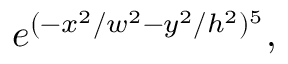Convert formula to latex. <formula><loc_0><loc_0><loc_500><loc_500>e ^ { ( - x ^ { 2 } / w ^ { 2 } - y ^ { 2 } / h ^ { 2 } ) ^ { 5 } } ,</formula> 